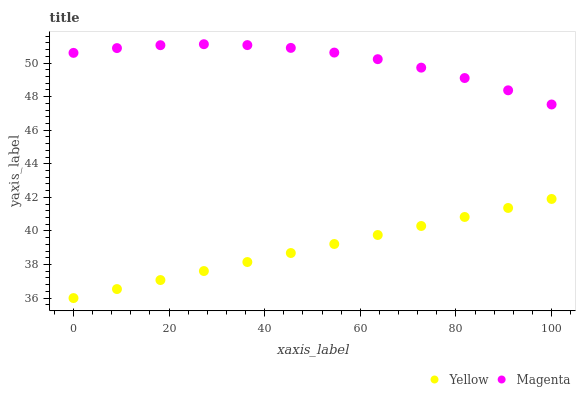Does Yellow have the minimum area under the curve?
Answer yes or no. Yes. Does Magenta have the maximum area under the curve?
Answer yes or no. Yes. Does Yellow have the maximum area under the curve?
Answer yes or no. No. Is Yellow the smoothest?
Answer yes or no. Yes. Is Magenta the roughest?
Answer yes or no. Yes. Is Yellow the roughest?
Answer yes or no. No. Does Yellow have the lowest value?
Answer yes or no. Yes. Does Magenta have the highest value?
Answer yes or no. Yes. Does Yellow have the highest value?
Answer yes or no. No. Is Yellow less than Magenta?
Answer yes or no. Yes. Is Magenta greater than Yellow?
Answer yes or no. Yes. Does Yellow intersect Magenta?
Answer yes or no. No. 